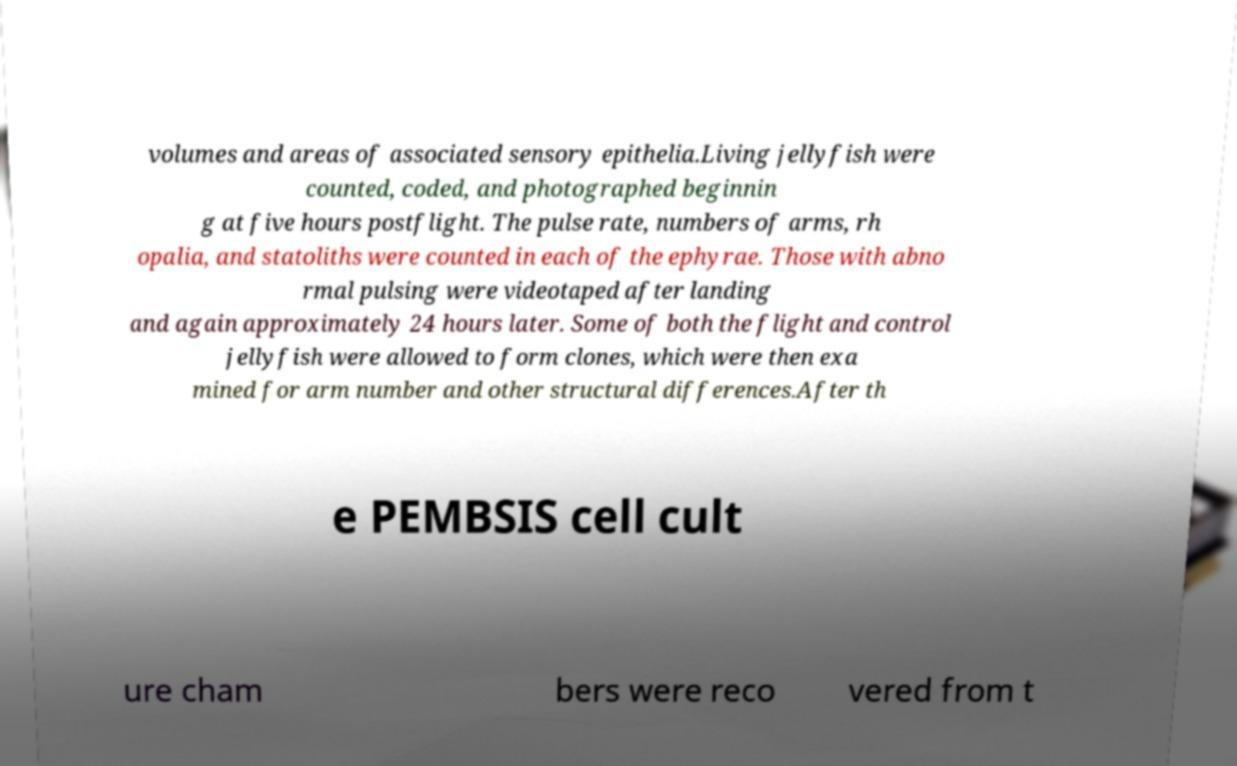Could you assist in decoding the text presented in this image and type it out clearly? volumes and areas of associated sensory epithelia.Living jellyfish were counted, coded, and photographed beginnin g at five hours postflight. The pulse rate, numbers of arms, rh opalia, and statoliths were counted in each of the ephyrae. Those with abno rmal pulsing were videotaped after landing and again approximately 24 hours later. Some of both the flight and control jellyfish were allowed to form clones, which were then exa mined for arm number and other structural differences.After th e PEMBSIS cell cult ure cham bers were reco vered from t 